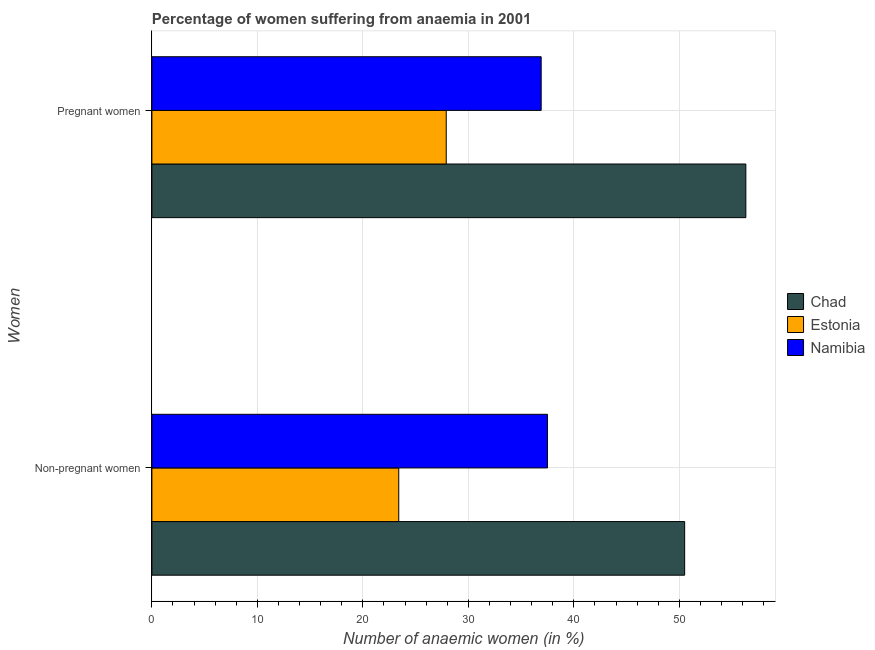How many different coloured bars are there?
Provide a short and direct response. 3. How many groups of bars are there?
Make the answer very short. 2. Are the number of bars on each tick of the Y-axis equal?
Your response must be concise. Yes. How many bars are there on the 1st tick from the bottom?
Your answer should be compact. 3. What is the label of the 2nd group of bars from the top?
Offer a very short reply. Non-pregnant women. What is the percentage of non-pregnant anaemic women in Chad?
Provide a short and direct response. 50.5. Across all countries, what is the maximum percentage of pregnant anaemic women?
Give a very brief answer. 56.3. Across all countries, what is the minimum percentage of non-pregnant anaemic women?
Your response must be concise. 23.4. In which country was the percentage of non-pregnant anaemic women maximum?
Make the answer very short. Chad. In which country was the percentage of pregnant anaemic women minimum?
Ensure brevity in your answer.  Estonia. What is the total percentage of non-pregnant anaemic women in the graph?
Provide a succinct answer. 111.4. What is the difference between the percentage of pregnant anaemic women in Chad and that in Namibia?
Provide a short and direct response. 19.4. What is the difference between the percentage of pregnant anaemic women in Chad and the percentage of non-pregnant anaemic women in Estonia?
Give a very brief answer. 32.9. What is the average percentage of pregnant anaemic women per country?
Provide a short and direct response. 40.37. What is the ratio of the percentage of non-pregnant anaemic women in Namibia to that in Chad?
Your answer should be very brief. 0.74. What does the 1st bar from the top in Pregnant women represents?
Your answer should be very brief. Namibia. What does the 2nd bar from the bottom in Non-pregnant women represents?
Keep it short and to the point. Estonia. How many bars are there?
Keep it short and to the point. 6. What is the difference between two consecutive major ticks on the X-axis?
Provide a short and direct response. 10. Where does the legend appear in the graph?
Offer a very short reply. Center right. What is the title of the graph?
Make the answer very short. Percentage of women suffering from anaemia in 2001. Does "Peru" appear as one of the legend labels in the graph?
Your answer should be very brief. No. What is the label or title of the X-axis?
Give a very brief answer. Number of anaemic women (in %). What is the label or title of the Y-axis?
Make the answer very short. Women. What is the Number of anaemic women (in %) in Chad in Non-pregnant women?
Provide a succinct answer. 50.5. What is the Number of anaemic women (in %) in Estonia in Non-pregnant women?
Keep it short and to the point. 23.4. What is the Number of anaemic women (in %) in Namibia in Non-pregnant women?
Ensure brevity in your answer.  37.5. What is the Number of anaemic women (in %) in Chad in Pregnant women?
Make the answer very short. 56.3. What is the Number of anaemic women (in %) in Estonia in Pregnant women?
Your answer should be very brief. 27.9. What is the Number of anaemic women (in %) of Namibia in Pregnant women?
Provide a succinct answer. 36.9. Across all Women, what is the maximum Number of anaemic women (in %) of Chad?
Your answer should be compact. 56.3. Across all Women, what is the maximum Number of anaemic women (in %) in Estonia?
Ensure brevity in your answer.  27.9. Across all Women, what is the maximum Number of anaemic women (in %) of Namibia?
Your response must be concise. 37.5. Across all Women, what is the minimum Number of anaemic women (in %) of Chad?
Provide a short and direct response. 50.5. Across all Women, what is the minimum Number of anaemic women (in %) of Estonia?
Offer a terse response. 23.4. Across all Women, what is the minimum Number of anaemic women (in %) in Namibia?
Your response must be concise. 36.9. What is the total Number of anaemic women (in %) of Chad in the graph?
Offer a very short reply. 106.8. What is the total Number of anaemic women (in %) in Estonia in the graph?
Ensure brevity in your answer.  51.3. What is the total Number of anaemic women (in %) of Namibia in the graph?
Offer a terse response. 74.4. What is the difference between the Number of anaemic women (in %) of Chad in Non-pregnant women and that in Pregnant women?
Keep it short and to the point. -5.8. What is the difference between the Number of anaemic women (in %) in Estonia in Non-pregnant women and that in Pregnant women?
Make the answer very short. -4.5. What is the difference between the Number of anaemic women (in %) in Chad in Non-pregnant women and the Number of anaemic women (in %) in Estonia in Pregnant women?
Provide a short and direct response. 22.6. What is the difference between the Number of anaemic women (in %) in Estonia in Non-pregnant women and the Number of anaemic women (in %) in Namibia in Pregnant women?
Provide a succinct answer. -13.5. What is the average Number of anaemic women (in %) in Chad per Women?
Ensure brevity in your answer.  53.4. What is the average Number of anaemic women (in %) in Estonia per Women?
Your response must be concise. 25.65. What is the average Number of anaemic women (in %) in Namibia per Women?
Your response must be concise. 37.2. What is the difference between the Number of anaemic women (in %) of Chad and Number of anaemic women (in %) of Estonia in Non-pregnant women?
Your response must be concise. 27.1. What is the difference between the Number of anaemic women (in %) of Chad and Number of anaemic women (in %) of Namibia in Non-pregnant women?
Your response must be concise. 13. What is the difference between the Number of anaemic women (in %) of Estonia and Number of anaemic women (in %) of Namibia in Non-pregnant women?
Keep it short and to the point. -14.1. What is the difference between the Number of anaemic women (in %) in Chad and Number of anaemic women (in %) in Estonia in Pregnant women?
Provide a short and direct response. 28.4. What is the difference between the Number of anaemic women (in %) in Chad and Number of anaemic women (in %) in Namibia in Pregnant women?
Your answer should be very brief. 19.4. What is the difference between the Number of anaemic women (in %) of Estonia and Number of anaemic women (in %) of Namibia in Pregnant women?
Offer a terse response. -9. What is the ratio of the Number of anaemic women (in %) of Chad in Non-pregnant women to that in Pregnant women?
Offer a very short reply. 0.9. What is the ratio of the Number of anaemic women (in %) of Estonia in Non-pregnant women to that in Pregnant women?
Make the answer very short. 0.84. What is the ratio of the Number of anaemic women (in %) in Namibia in Non-pregnant women to that in Pregnant women?
Keep it short and to the point. 1.02. What is the difference between the highest and the second highest Number of anaemic women (in %) of Estonia?
Give a very brief answer. 4.5. What is the difference between the highest and the second highest Number of anaemic women (in %) in Namibia?
Give a very brief answer. 0.6. What is the difference between the highest and the lowest Number of anaemic women (in %) in Chad?
Ensure brevity in your answer.  5.8. What is the difference between the highest and the lowest Number of anaemic women (in %) in Estonia?
Make the answer very short. 4.5. 